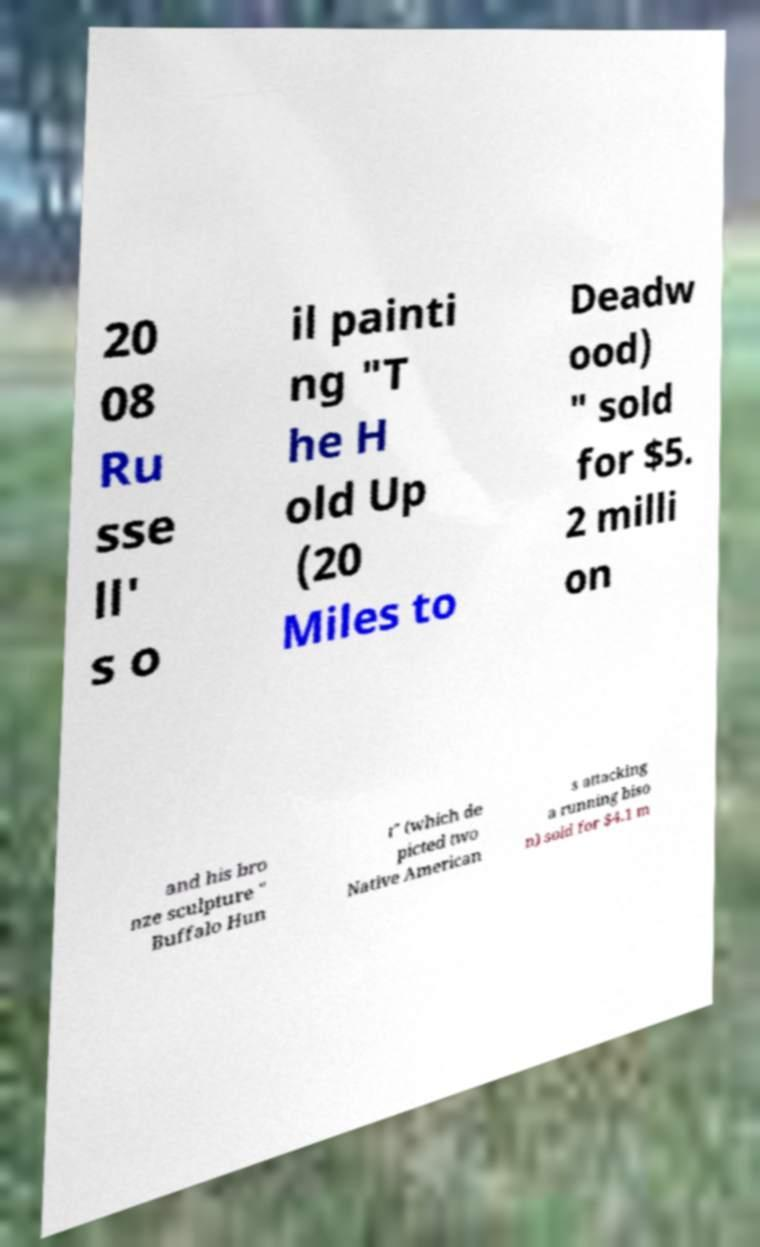Could you assist in decoding the text presented in this image and type it out clearly? 20 08 Ru sse ll' s o il painti ng "T he H old Up (20 Miles to Deadw ood) " sold for $5. 2 milli on and his bro nze sculpture " Buffalo Hun t" (which de picted two Native American s attacking a running biso n) sold for $4.1 m 